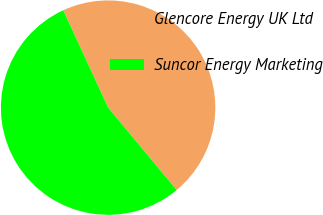<chart> <loc_0><loc_0><loc_500><loc_500><pie_chart><fcel>Glencore Energy UK Ltd<fcel>Suncor Energy Marketing<nl><fcel>45.83%<fcel>54.17%<nl></chart> 